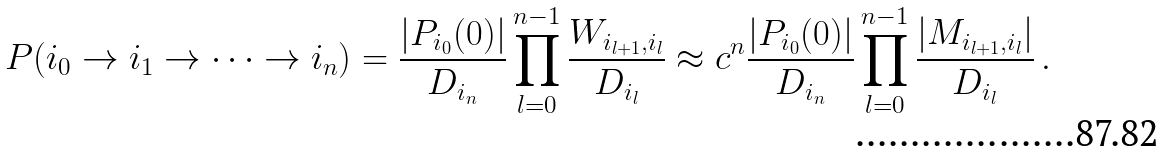Convert formula to latex. <formula><loc_0><loc_0><loc_500><loc_500>P ( i _ { 0 } \rightarrow i _ { 1 } \rightarrow \dots \rightarrow i _ { n } ) = \frac { | P _ { i _ { 0 } } ( 0 ) | } { D _ { i _ { n } } } \prod _ { l = 0 } ^ { n - 1 } \frac { W _ { i _ { l + 1 } , i _ { l } } } { D _ { i _ { l } } } \approx c ^ { n } \frac { | P _ { i _ { 0 } } ( 0 ) | } { D _ { i _ { n } } } \prod _ { l = 0 } ^ { n - 1 } \frac { | M _ { i _ { l + 1 } , i _ { l } } | } { D _ { i _ { l } } } \, .</formula> 